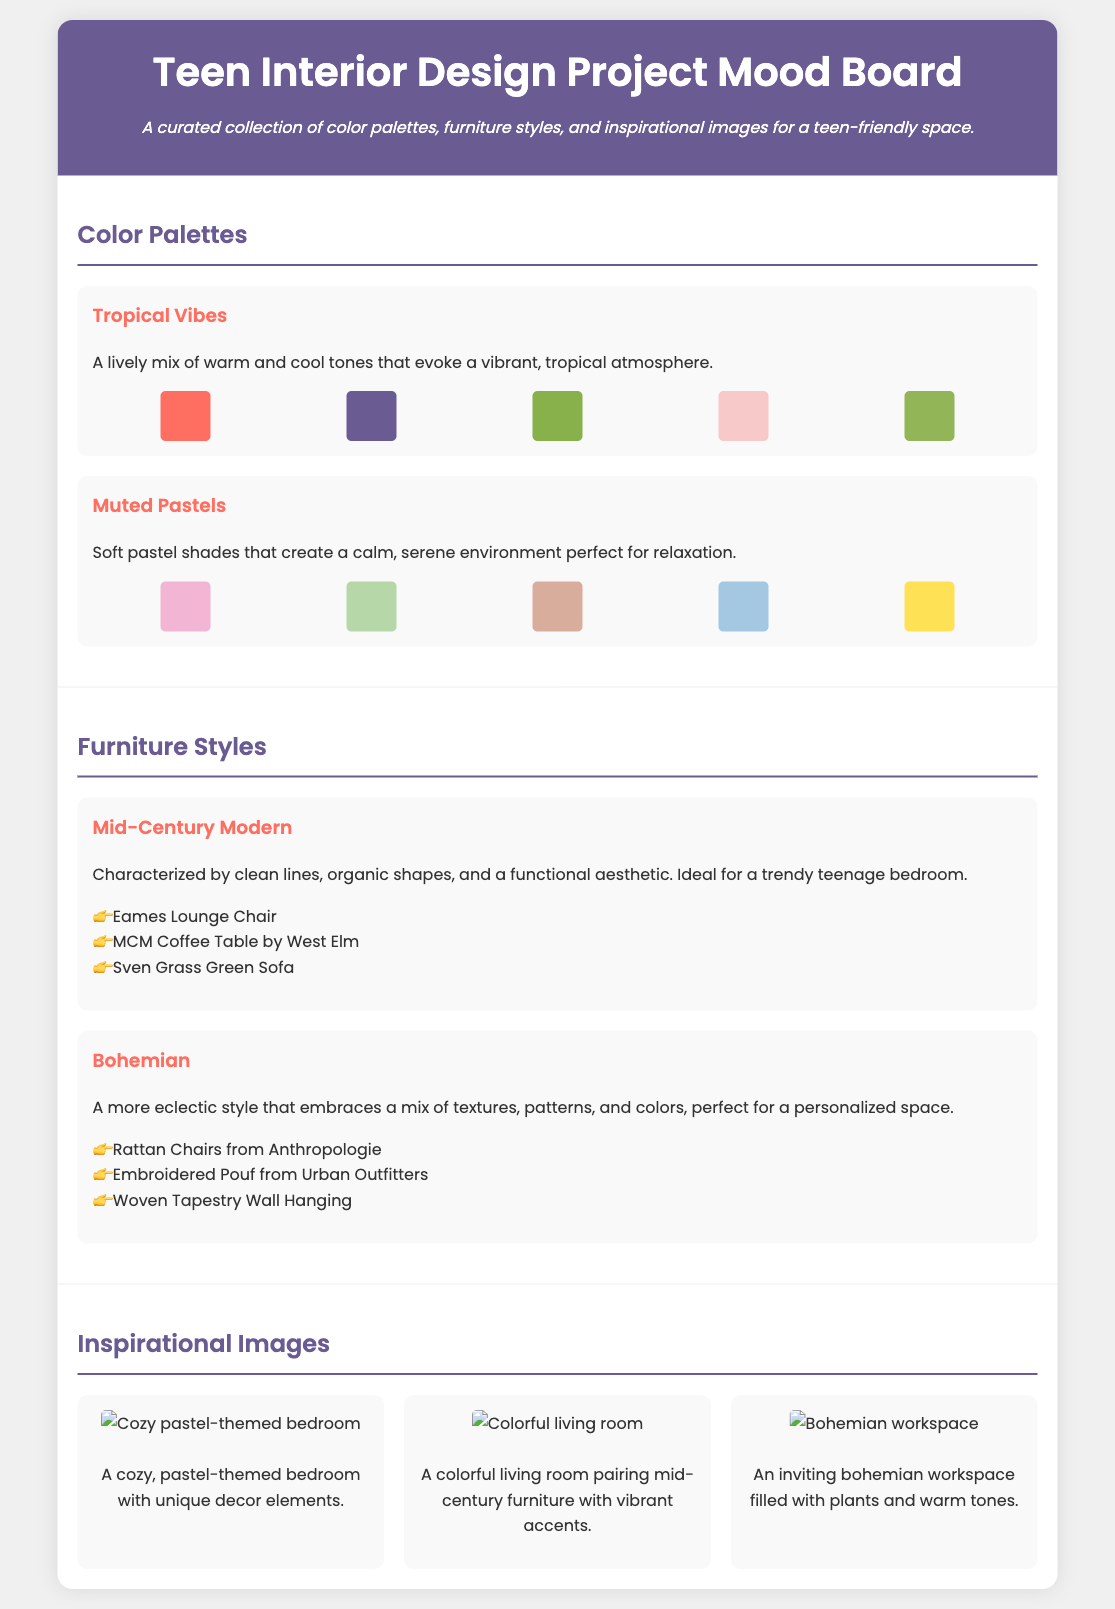What are the two color palettes featured? The document includes two color palettes named "Tropical Vibes" and "Muted Pastels."
Answer: Tropical Vibes, Muted Pastels What is the characteristic style of furniture described in the "Mid-Century Modern" section? The "Mid-Century Modern" style is characterized by clean lines, organic shapes, and a functional aesthetic.
Answer: Clean lines, organic shapes, functional aesthetic How many color squares are shown in the "Tropical Vibes" palette? The "Tropical Vibes" palette displays five color squares.
Answer: Five Name one piece of furniture listed under the Bohemian style. One of the furniture styles listed under Bohemian is the "Embroidered Pouf from Urban Outfitters."
Answer: Embroidered Pouf from Urban Outfitters What is the mood of the "Muted Pastels" palette? The "Muted Pastels" palette is described as creating a calm, serene environment perfect for relaxation.
Answer: Calm, serene environment How many furniture examples are provided for the Mid-Century Modern style? There are three furniture examples provided for the Mid-Century Modern style.
Answer: Three What is the color of the Eames Lounge Chair? The document does not specify the color of the Eames Lounge Chair, only mentions it as an example.
Answer: Not specified Which image depicts a bohemian workspace? The image that shows an inviting bohemian workspace filled with plants and warm tones.
Answer: The inviting bohemian workspace image 